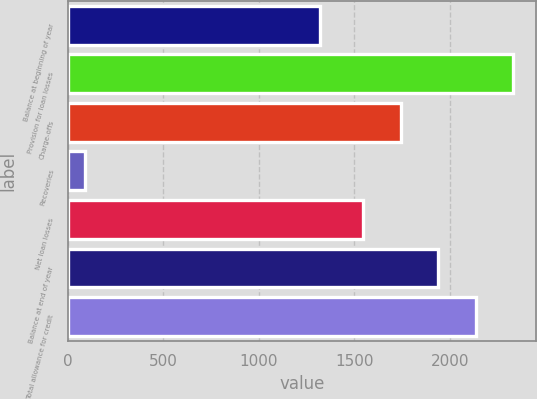<chart> <loc_0><loc_0><loc_500><loc_500><bar_chart><fcel>Balance at beginning of year<fcel>Provision for loan losses<fcel>Charge-offs<fcel>Recoveries<fcel>Net loan losses<fcel>Balance at end of year<fcel>Total allowance for credit<nl><fcel>1321<fcel>2333<fcel>1743.5<fcel>92<fcel>1547<fcel>1940<fcel>2136.5<nl></chart> 